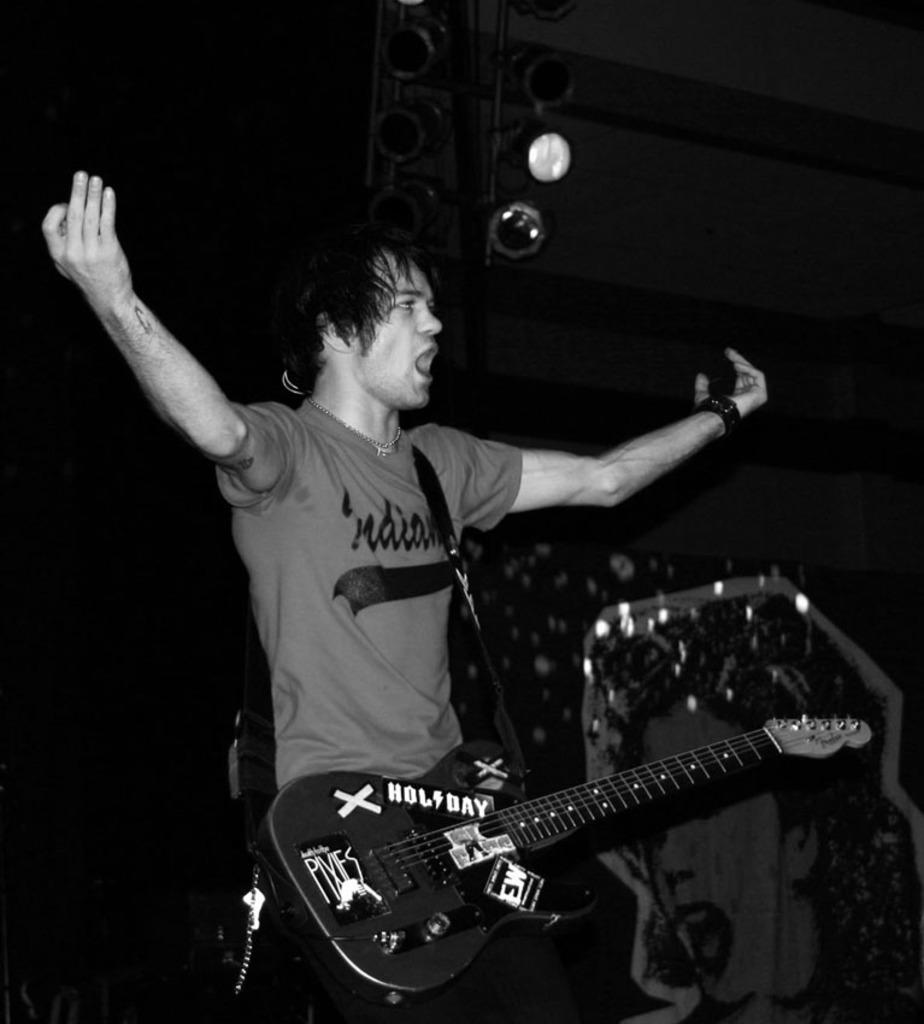What is the man in the image holding? The man is holding a guitar. What is the man doing with his arms? The man is spreading his arms. What might the man be doing based on his actions? The man appears to be singing. What other musical instruments can be seen in the image? There are other musical instruments visible in the image. What can be seen in the image that might provide lighting? There are lights present in the image. What type of mint can be seen growing near the man in the image? There is no mint visible in the image; it features a man holding a guitar and other musical instruments. 